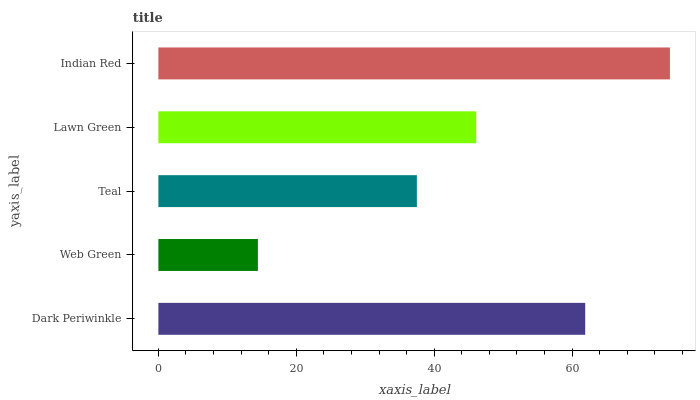Is Web Green the minimum?
Answer yes or no. Yes. Is Indian Red the maximum?
Answer yes or no. Yes. Is Teal the minimum?
Answer yes or no. No. Is Teal the maximum?
Answer yes or no. No. Is Teal greater than Web Green?
Answer yes or no. Yes. Is Web Green less than Teal?
Answer yes or no. Yes. Is Web Green greater than Teal?
Answer yes or no. No. Is Teal less than Web Green?
Answer yes or no. No. Is Lawn Green the high median?
Answer yes or no. Yes. Is Lawn Green the low median?
Answer yes or no. Yes. Is Dark Periwinkle the high median?
Answer yes or no. No. Is Web Green the low median?
Answer yes or no. No. 